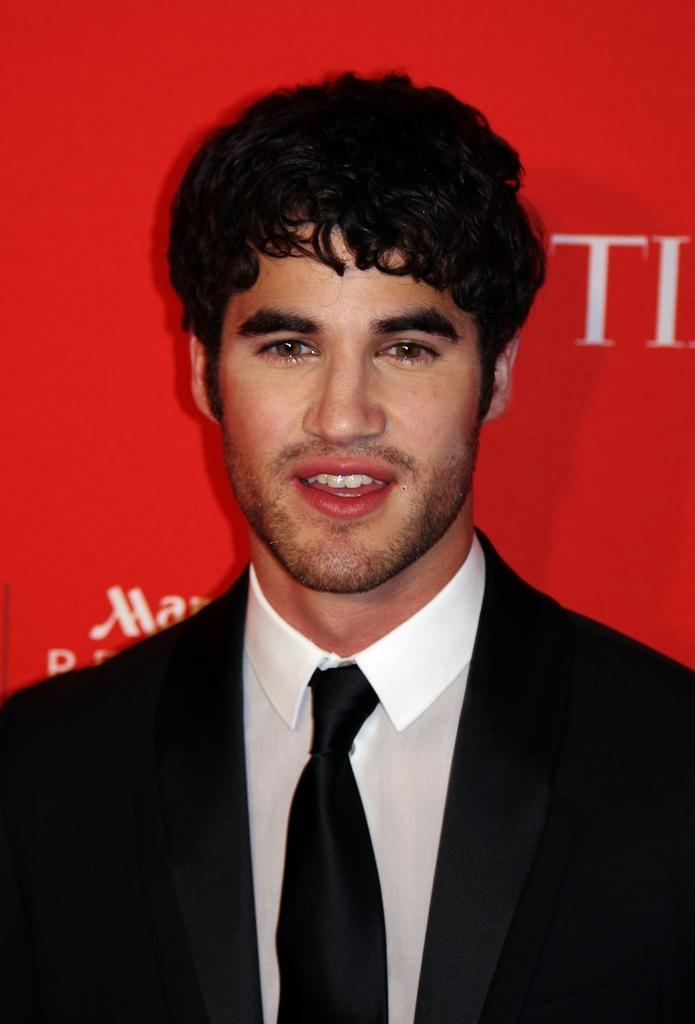Please provide a concise description of this image. A man is wearing black color suit, there is red color background. 